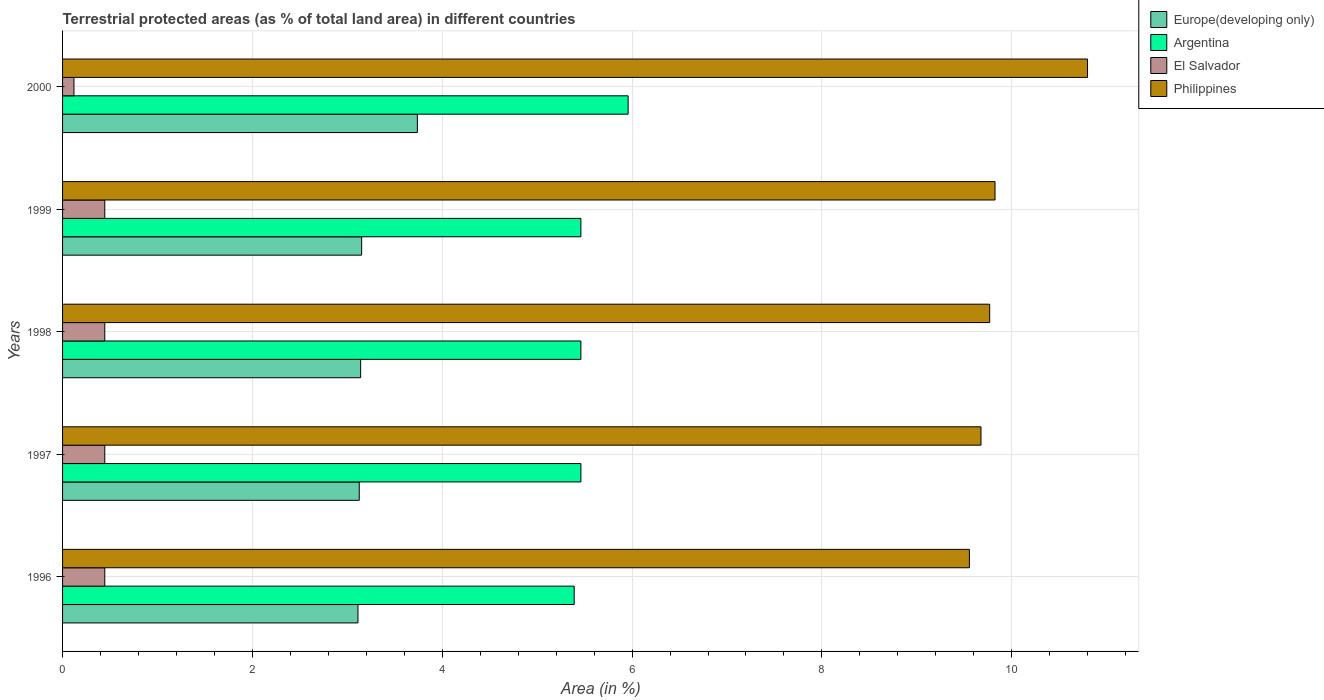How many groups of bars are there?
Ensure brevity in your answer.  5. Are the number of bars on each tick of the Y-axis equal?
Keep it short and to the point. Yes. How many bars are there on the 3rd tick from the bottom?
Provide a short and direct response. 4. What is the label of the 3rd group of bars from the top?
Ensure brevity in your answer.  1998. What is the percentage of terrestrial protected land in Argentina in 2000?
Make the answer very short. 5.96. Across all years, what is the maximum percentage of terrestrial protected land in Argentina?
Offer a terse response. 5.96. Across all years, what is the minimum percentage of terrestrial protected land in Philippines?
Provide a succinct answer. 9.55. In which year was the percentage of terrestrial protected land in Philippines maximum?
Provide a short and direct response. 2000. In which year was the percentage of terrestrial protected land in Europe(developing only) minimum?
Your response must be concise. 1996. What is the total percentage of terrestrial protected land in El Salvador in the graph?
Your response must be concise. 1.9. What is the difference between the percentage of terrestrial protected land in Europe(developing only) in 1996 and that in 1999?
Keep it short and to the point. -0.04. What is the difference between the percentage of terrestrial protected land in Argentina in 1996 and the percentage of terrestrial protected land in El Salvador in 1998?
Your answer should be very brief. 4.95. What is the average percentage of terrestrial protected land in Argentina per year?
Offer a very short reply. 5.55. In the year 1996, what is the difference between the percentage of terrestrial protected land in El Salvador and percentage of terrestrial protected land in Europe(developing only)?
Provide a short and direct response. -2.67. In how many years, is the percentage of terrestrial protected land in Philippines greater than 0.8 %?
Make the answer very short. 5. What is the ratio of the percentage of terrestrial protected land in Philippines in 1996 to that in 2000?
Your response must be concise. 0.88. Is the percentage of terrestrial protected land in El Salvador in 1996 less than that in 2000?
Offer a very short reply. No. Is the difference between the percentage of terrestrial protected land in El Salvador in 1996 and 2000 greater than the difference between the percentage of terrestrial protected land in Europe(developing only) in 1996 and 2000?
Keep it short and to the point. Yes. What is the difference between the highest and the second highest percentage of terrestrial protected land in El Salvador?
Your answer should be very brief. 0. What is the difference between the highest and the lowest percentage of terrestrial protected land in Europe(developing only)?
Offer a terse response. 0.63. Is the sum of the percentage of terrestrial protected land in El Salvador in 1999 and 2000 greater than the maximum percentage of terrestrial protected land in Argentina across all years?
Provide a short and direct response. No. What does the 4th bar from the top in 1997 represents?
Your response must be concise. Europe(developing only). What does the 2nd bar from the bottom in 1996 represents?
Your answer should be very brief. Argentina. Is it the case that in every year, the sum of the percentage of terrestrial protected land in Europe(developing only) and percentage of terrestrial protected land in El Salvador is greater than the percentage of terrestrial protected land in Philippines?
Provide a succinct answer. No. Are all the bars in the graph horizontal?
Give a very brief answer. Yes. How many years are there in the graph?
Offer a terse response. 5. What is the difference between two consecutive major ticks on the X-axis?
Give a very brief answer. 2. Are the values on the major ticks of X-axis written in scientific E-notation?
Ensure brevity in your answer.  No. How many legend labels are there?
Give a very brief answer. 4. What is the title of the graph?
Provide a short and direct response. Terrestrial protected areas (as % of total land area) in different countries. What is the label or title of the X-axis?
Offer a very short reply. Area (in %). What is the label or title of the Y-axis?
Provide a succinct answer. Years. What is the Area (in %) of Europe(developing only) in 1996?
Give a very brief answer. 3.11. What is the Area (in %) of Argentina in 1996?
Offer a terse response. 5.39. What is the Area (in %) of El Salvador in 1996?
Your answer should be compact. 0.44. What is the Area (in %) of Philippines in 1996?
Your answer should be very brief. 9.55. What is the Area (in %) in Europe(developing only) in 1997?
Offer a terse response. 3.13. What is the Area (in %) of Argentina in 1997?
Provide a succinct answer. 5.46. What is the Area (in %) in El Salvador in 1997?
Your answer should be compact. 0.44. What is the Area (in %) of Philippines in 1997?
Ensure brevity in your answer.  9.68. What is the Area (in %) of Europe(developing only) in 1998?
Your response must be concise. 3.14. What is the Area (in %) in Argentina in 1998?
Your answer should be very brief. 5.46. What is the Area (in %) in El Salvador in 1998?
Keep it short and to the point. 0.44. What is the Area (in %) of Philippines in 1998?
Offer a very short reply. 9.77. What is the Area (in %) in Europe(developing only) in 1999?
Your response must be concise. 3.15. What is the Area (in %) in Argentina in 1999?
Offer a very short reply. 5.46. What is the Area (in %) in El Salvador in 1999?
Offer a terse response. 0.44. What is the Area (in %) in Philippines in 1999?
Offer a terse response. 9.82. What is the Area (in %) of Europe(developing only) in 2000?
Your answer should be compact. 3.74. What is the Area (in %) of Argentina in 2000?
Your answer should be compact. 5.96. What is the Area (in %) of El Salvador in 2000?
Make the answer very short. 0.12. What is the Area (in %) of Philippines in 2000?
Your answer should be compact. 10.8. Across all years, what is the maximum Area (in %) in Europe(developing only)?
Offer a very short reply. 3.74. Across all years, what is the maximum Area (in %) of Argentina?
Provide a short and direct response. 5.96. Across all years, what is the maximum Area (in %) of El Salvador?
Offer a terse response. 0.44. Across all years, what is the maximum Area (in %) of Philippines?
Your response must be concise. 10.8. Across all years, what is the minimum Area (in %) in Europe(developing only)?
Offer a terse response. 3.11. Across all years, what is the minimum Area (in %) of Argentina?
Ensure brevity in your answer.  5.39. Across all years, what is the minimum Area (in %) in El Salvador?
Offer a terse response. 0.12. Across all years, what is the minimum Area (in %) in Philippines?
Provide a succinct answer. 9.55. What is the total Area (in %) in Europe(developing only) in the graph?
Make the answer very short. 16.27. What is the total Area (in %) of Argentina in the graph?
Your response must be concise. 27.73. What is the total Area (in %) of El Salvador in the graph?
Offer a terse response. 1.9. What is the total Area (in %) in Philippines in the graph?
Keep it short and to the point. 49.62. What is the difference between the Area (in %) of Europe(developing only) in 1996 and that in 1997?
Offer a terse response. -0.01. What is the difference between the Area (in %) of Argentina in 1996 and that in 1997?
Offer a very short reply. -0.07. What is the difference between the Area (in %) of Philippines in 1996 and that in 1997?
Offer a terse response. -0.12. What is the difference between the Area (in %) of Europe(developing only) in 1996 and that in 1998?
Your answer should be compact. -0.03. What is the difference between the Area (in %) in Argentina in 1996 and that in 1998?
Your answer should be very brief. -0.07. What is the difference between the Area (in %) of El Salvador in 1996 and that in 1998?
Provide a succinct answer. 0. What is the difference between the Area (in %) of Philippines in 1996 and that in 1998?
Your answer should be compact. -0.21. What is the difference between the Area (in %) in Europe(developing only) in 1996 and that in 1999?
Provide a short and direct response. -0.04. What is the difference between the Area (in %) of Argentina in 1996 and that in 1999?
Provide a succinct answer. -0.07. What is the difference between the Area (in %) of El Salvador in 1996 and that in 1999?
Ensure brevity in your answer.  0. What is the difference between the Area (in %) of Philippines in 1996 and that in 1999?
Keep it short and to the point. -0.27. What is the difference between the Area (in %) of Europe(developing only) in 1996 and that in 2000?
Your response must be concise. -0.63. What is the difference between the Area (in %) of Argentina in 1996 and that in 2000?
Keep it short and to the point. -0.57. What is the difference between the Area (in %) in El Salvador in 1996 and that in 2000?
Offer a terse response. 0.32. What is the difference between the Area (in %) in Philippines in 1996 and that in 2000?
Make the answer very short. -1.24. What is the difference between the Area (in %) of Europe(developing only) in 1997 and that in 1998?
Ensure brevity in your answer.  -0.01. What is the difference between the Area (in %) in Argentina in 1997 and that in 1998?
Your answer should be compact. -0. What is the difference between the Area (in %) of El Salvador in 1997 and that in 1998?
Make the answer very short. 0. What is the difference between the Area (in %) of Philippines in 1997 and that in 1998?
Your answer should be compact. -0.09. What is the difference between the Area (in %) of Europe(developing only) in 1997 and that in 1999?
Make the answer very short. -0.03. What is the difference between the Area (in %) of Philippines in 1997 and that in 1999?
Offer a terse response. -0.15. What is the difference between the Area (in %) of Europe(developing only) in 1997 and that in 2000?
Your answer should be very brief. -0.61. What is the difference between the Area (in %) of Argentina in 1997 and that in 2000?
Provide a short and direct response. -0.5. What is the difference between the Area (in %) of El Salvador in 1997 and that in 2000?
Your response must be concise. 0.32. What is the difference between the Area (in %) in Philippines in 1997 and that in 2000?
Your answer should be compact. -1.12. What is the difference between the Area (in %) of Europe(developing only) in 1998 and that in 1999?
Give a very brief answer. -0.01. What is the difference between the Area (in %) in El Salvador in 1998 and that in 1999?
Make the answer very short. 0. What is the difference between the Area (in %) in Philippines in 1998 and that in 1999?
Offer a terse response. -0.06. What is the difference between the Area (in %) in Europe(developing only) in 1998 and that in 2000?
Offer a terse response. -0.6. What is the difference between the Area (in %) of Argentina in 1998 and that in 2000?
Provide a short and direct response. -0.5. What is the difference between the Area (in %) of El Salvador in 1998 and that in 2000?
Ensure brevity in your answer.  0.32. What is the difference between the Area (in %) of Philippines in 1998 and that in 2000?
Provide a succinct answer. -1.03. What is the difference between the Area (in %) in Europe(developing only) in 1999 and that in 2000?
Give a very brief answer. -0.59. What is the difference between the Area (in %) of Argentina in 1999 and that in 2000?
Offer a very short reply. -0.5. What is the difference between the Area (in %) of El Salvador in 1999 and that in 2000?
Your response must be concise. 0.32. What is the difference between the Area (in %) in Philippines in 1999 and that in 2000?
Provide a succinct answer. -0.97. What is the difference between the Area (in %) of Europe(developing only) in 1996 and the Area (in %) of Argentina in 1997?
Offer a very short reply. -2.35. What is the difference between the Area (in %) in Europe(developing only) in 1996 and the Area (in %) in El Salvador in 1997?
Ensure brevity in your answer.  2.67. What is the difference between the Area (in %) in Europe(developing only) in 1996 and the Area (in %) in Philippines in 1997?
Your answer should be very brief. -6.56. What is the difference between the Area (in %) of Argentina in 1996 and the Area (in %) of El Salvador in 1997?
Provide a short and direct response. 4.95. What is the difference between the Area (in %) of Argentina in 1996 and the Area (in %) of Philippines in 1997?
Provide a succinct answer. -4.29. What is the difference between the Area (in %) in El Salvador in 1996 and the Area (in %) in Philippines in 1997?
Give a very brief answer. -9.23. What is the difference between the Area (in %) in Europe(developing only) in 1996 and the Area (in %) in Argentina in 1998?
Offer a very short reply. -2.35. What is the difference between the Area (in %) of Europe(developing only) in 1996 and the Area (in %) of El Salvador in 1998?
Provide a succinct answer. 2.67. What is the difference between the Area (in %) in Europe(developing only) in 1996 and the Area (in %) in Philippines in 1998?
Offer a very short reply. -6.66. What is the difference between the Area (in %) in Argentina in 1996 and the Area (in %) in El Salvador in 1998?
Ensure brevity in your answer.  4.95. What is the difference between the Area (in %) of Argentina in 1996 and the Area (in %) of Philippines in 1998?
Your answer should be very brief. -4.38. What is the difference between the Area (in %) in El Salvador in 1996 and the Area (in %) in Philippines in 1998?
Make the answer very short. -9.32. What is the difference between the Area (in %) in Europe(developing only) in 1996 and the Area (in %) in Argentina in 1999?
Ensure brevity in your answer.  -2.35. What is the difference between the Area (in %) in Europe(developing only) in 1996 and the Area (in %) in El Salvador in 1999?
Offer a terse response. 2.67. What is the difference between the Area (in %) of Europe(developing only) in 1996 and the Area (in %) of Philippines in 1999?
Keep it short and to the point. -6.71. What is the difference between the Area (in %) of Argentina in 1996 and the Area (in %) of El Salvador in 1999?
Provide a succinct answer. 4.95. What is the difference between the Area (in %) in Argentina in 1996 and the Area (in %) in Philippines in 1999?
Your answer should be very brief. -4.43. What is the difference between the Area (in %) of El Salvador in 1996 and the Area (in %) of Philippines in 1999?
Keep it short and to the point. -9.38. What is the difference between the Area (in %) of Europe(developing only) in 1996 and the Area (in %) of Argentina in 2000?
Keep it short and to the point. -2.85. What is the difference between the Area (in %) in Europe(developing only) in 1996 and the Area (in %) in El Salvador in 2000?
Your response must be concise. 2.99. What is the difference between the Area (in %) in Europe(developing only) in 1996 and the Area (in %) in Philippines in 2000?
Your answer should be compact. -7.69. What is the difference between the Area (in %) in Argentina in 1996 and the Area (in %) in El Salvador in 2000?
Offer a terse response. 5.27. What is the difference between the Area (in %) of Argentina in 1996 and the Area (in %) of Philippines in 2000?
Your response must be concise. -5.41. What is the difference between the Area (in %) in El Salvador in 1996 and the Area (in %) in Philippines in 2000?
Give a very brief answer. -10.35. What is the difference between the Area (in %) of Europe(developing only) in 1997 and the Area (in %) of Argentina in 1998?
Provide a succinct answer. -2.34. What is the difference between the Area (in %) in Europe(developing only) in 1997 and the Area (in %) in El Salvador in 1998?
Ensure brevity in your answer.  2.68. What is the difference between the Area (in %) in Europe(developing only) in 1997 and the Area (in %) in Philippines in 1998?
Provide a succinct answer. -6.64. What is the difference between the Area (in %) of Argentina in 1997 and the Area (in %) of El Salvador in 1998?
Keep it short and to the point. 5.02. What is the difference between the Area (in %) in Argentina in 1997 and the Area (in %) in Philippines in 1998?
Make the answer very short. -4.31. What is the difference between the Area (in %) in El Salvador in 1997 and the Area (in %) in Philippines in 1998?
Provide a succinct answer. -9.32. What is the difference between the Area (in %) in Europe(developing only) in 1997 and the Area (in %) in Argentina in 1999?
Keep it short and to the point. -2.34. What is the difference between the Area (in %) in Europe(developing only) in 1997 and the Area (in %) in El Salvador in 1999?
Offer a terse response. 2.68. What is the difference between the Area (in %) in Europe(developing only) in 1997 and the Area (in %) in Philippines in 1999?
Ensure brevity in your answer.  -6.7. What is the difference between the Area (in %) in Argentina in 1997 and the Area (in %) in El Salvador in 1999?
Provide a succinct answer. 5.02. What is the difference between the Area (in %) in Argentina in 1997 and the Area (in %) in Philippines in 1999?
Make the answer very short. -4.36. What is the difference between the Area (in %) of El Salvador in 1997 and the Area (in %) of Philippines in 1999?
Give a very brief answer. -9.38. What is the difference between the Area (in %) of Europe(developing only) in 1997 and the Area (in %) of Argentina in 2000?
Offer a very short reply. -2.83. What is the difference between the Area (in %) in Europe(developing only) in 1997 and the Area (in %) in El Salvador in 2000?
Offer a terse response. 3.01. What is the difference between the Area (in %) in Europe(developing only) in 1997 and the Area (in %) in Philippines in 2000?
Your response must be concise. -7.67. What is the difference between the Area (in %) of Argentina in 1997 and the Area (in %) of El Salvador in 2000?
Your answer should be very brief. 5.34. What is the difference between the Area (in %) in Argentina in 1997 and the Area (in %) in Philippines in 2000?
Provide a short and direct response. -5.34. What is the difference between the Area (in %) in El Salvador in 1997 and the Area (in %) in Philippines in 2000?
Your answer should be compact. -10.35. What is the difference between the Area (in %) in Europe(developing only) in 1998 and the Area (in %) in Argentina in 1999?
Your answer should be very brief. -2.32. What is the difference between the Area (in %) in Europe(developing only) in 1998 and the Area (in %) in El Salvador in 1999?
Your response must be concise. 2.7. What is the difference between the Area (in %) in Europe(developing only) in 1998 and the Area (in %) in Philippines in 1999?
Give a very brief answer. -6.68. What is the difference between the Area (in %) in Argentina in 1998 and the Area (in %) in El Salvador in 1999?
Your answer should be compact. 5.02. What is the difference between the Area (in %) in Argentina in 1998 and the Area (in %) in Philippines in 1999?
Make the answer very short. -4.36. What is the difference between the Area (in %) of El Salvador in 1998 and the Area (in %) of Philippines in 1999?
Make the answer very short. -9.38. What is the difference between the Area (in %) of Europe(developing only) in 1998 and the Area (in %) of Argentina in 2000?
Keep it short and to the point. -2.82. What is the difference between the Area (in %) in Europe(developing only) in 1998 and the Area (in %) in El Salvador in 2000?
Provide a succinct answer. 3.02. What is the difference between the Area (in %) of Europe(developing only) in 1998 and the Area (in %) of Philippines in 2000?
Give a very brief answer. -7.66. What is the difference between the Area (in %) of Argentina in 1998 and the Area (in %) of El Salvador in 2000?
Keep it short and to the point. 5.34. What is the difference between the Area (in %) in Argentina in 1998 and the Area (in %) in Philippines in 2000?
Offer a terse response. -5.34. What is the difference between the Area (in %) in El Salvador in 1998 and the Area (in %) in Philippines in 2000?
Provide a succinct answer. -10.35. What is the difference between the Area (in %) in Europe(developing only) in 1999 and the Area (in %) in Argentina in 2000?
Give a very brief answer. -2.81. What is the difference between the Area (in %) of Europe(developing only) in 1999 and the Area (in %) of El Salvador in 2000?
Make the answer very short. 3.03. What is the difference between the Area (in %) in Europe(developing only) in 1999 and the Area (in %) in Philippines in 2000?
Give a very brief answer. -7.65. What is the difference between the Area (in %) in Argentina in 1999 and the Area (in %) in El Salvador in 2000?
Your answer should be very brief. 5.34. What is the difference between the Area (in %) of Argentina in 1999 and the Area (in %) of Philippines in 2000?
Your answer should be very brief. -5.34. What is the difference between the Area (in %) in El Salvador in 1999 and the Area (in %) in Philippines in 2000?
Ensure brevity in your answer.  -10.35. What is the average Area (in %) in Europe(developing only) per year?
Provide a succinct answer. 3.25. What is the average Area (in %) in Argentina per year?
Keep it short and to the point. 5.55. What is the average Area (in %) in El Salvador per year?
Your response must be concise. 0.38. What is the average Area (in %) in Philippines per year?
Offer a very short reply. 9.92. In the year 1996, what is the difference between the Area (in %) in Europe(developing only) and Area (in %) in Argentina?
Ensure brevity in your answer.  -2.28. In the year 1996, what is the difference between the Area (in %) of Europe(developing only) and Area (in %) of El Salvador?
Make the answer very short. 2.67. In the year 1996, what is the difference between the Area (in %) in Europe(developing only) and Area (in %) in Philippines?
Provide a short and direct response. -6.44. In the year 1996, what is the difference between the Area (in %) in Argentina and Area (in %) in El Salvador?
Ensure brevity in your answer.  4.95. In the year 1996, what is the difference between the Area (in %) in Argentina and Area (in %) in Philippines?
Provide a short and direct response. -4.16. In the year 1996, what is the difference between the Area (in %) of El Salvador and Area (in %) of Philippines?
Your response must be concise. -9.11. In the year 1997, what is the difference between the Area (in %) of Europe(developing only) and Area (in %) of Argentina?
Provide a succinct answer. -2.33. In the year 1997, what is the difference between the Area (in %) in Europe(developing only) and Area (in %) in El Salvador?
Offer a terse response. 2.68. In the year 1997, what is the difference between the Area (in %) in Europe(developing only) and Area (in %) in Philippines?
Your answer should be compact. -6.55. In the year 1997, what is the difference between the Area (in %) of Argentina and Area (in %) of El Salvador?
Provide a succinct answer. 5.02. In the year 1997, what is the difference between the Area (in %) of Argentina and Area (in %) of Philippines?
Give a very brief answer. -4.21. In the year 1997, what is the difference between the Area (in %) in El Salvador and Area (in %) in Philippines?
Give a very brief answer. -9.23. In the year 1998, what is the difference between the Area (in %) of Europe(developing only) and Area (in %) of Argentina?
Your response must be concise. -2.32. In the year 1998, what is the difference between the Area (in %) in Europe(developing only) and Area (in %) in El Salvador?
Ensure brevity in your answer.  2.7. In the year 1998, what is the difference between the Area (in %) of Europe(developing only) and Area (in %) of Philippines?
Make the answer very short. -6.63. In the year 1998, what is the difference between the Area (in %) of Argentina and Area (in %) of El Salvador?
Offer a very short reply. 5.02. In the year 1998, what is the difference between the Area (in %) in Argentina and Area (in %) in Philippines?
Ensure brevity in your answer.  -4.31. In the year 1998, what is the difference between the Area (in %) of El Salvador and Area (in %) of Philippines?
Make the answer very short. -9.32. In the year 1999, what is the difference between the Area (in %) of Europe(developing only) and Area (in %) of Argentina?
Offer a terse response. -2.31. In the year 1999, what is the difference between the Area (in %) in Europe(developing only) and Area (in %) in El Salvador?
Keep it short and to the point. 2.71. In the year 1999, what is the difference between the Area (in %) in Europe(developing only) and Area (in %) in Philippines?
Keep it short and to the point. -6.67. In the year 1999, what is the difference between the Area (in %) of Argentina and Area (in %) of El Salvador?
Offer a very short reply. 5.02. In the year 1999, what is the difference between the Area (in %) of Argentina and Area (in %) of Philippines?
Make the answer very short. -4.36. In the year 1999, what is the difference between the Area (in %) of El Salvador and Area (in %) of Philippines?
Your response must be concise. -9.38. In the year 2000, what is the difference between the Area (in %) in Europe(developing only) and Area (in %) in Argentina?
Provide a succinct answer. -2.22. In the year 2000, what is the difference between the Area (in %) of Europe(developing only) and Area (in %) of El Salvador?
Your response must be concise. 3.62. In the year 2000, what is the difference between the Area (in %) of Europe(developing only) and Area (in %) of Philippines?
Provide a succinct answer. -7.06. In the year 2000, what is the difference between the Area (in %) in Argentina and Area (in %) in El Salvador?
Keep it short and to the point. 5.84. In the year 2000, what is the difference between the Area (in %) of Argentina and Area (in %) of Philippines?
Provide a succinct answer. -4.84. In the year 2000, what is the difference between the Area (in %) of El Salvador and Area (in %) of Philippines?
Make the answer very short. -10.68. What is the ratio of the Area (in %) in Argentina in 1996 to that in 1997?
Provide a succinct answer. 0.99. What is the ratio of the Area (in %) of Philippines in 1996 to that in 1997?
Your answer should be compact. 0.99. What is the ratio of the Area (in %) of Europe(developing only) in 1996 to that in 1998?
Your response must be concise. 0.99. What is the ratio of the Area (in %) of El Salvador in 1996 to that in 1998?
Your answer should be very brief. 1. What is the ratio of the Area (in %) of Philippines in 1996 to that in 1998?
Provide a short and direct response. 0.98. What is the ratio of the Area (in %) of Argentina in 1996 to that in 1999?
Your answer should be compact. 0.99. What is the ratio of the Area (in %) of El Salvador in 1996 to that in 1999?
Your response must be concise. 1. What is the ratio of the Area (in %) of Philippines in 1996 to that in 1999?
Offer a terse response. 0.97. What is the ratio of the Area (in %) of Europe(developing only) in 1996 to that in 2000?
Your response must be concise. 0.83. What is the ratio of the Area (in %) in Argentina in 1996 to that in 2000?
Provide a succinct answer. 0.9. What is the ratio of the Area (in %) in El Salvador in 1996 to that in 2000?
Make the answer very short. 3.7. What is the ratio of the Area (in %) in Philippines in 1996 to that in 2000?
Ensure brevity in your answer.  0.88. What is the ratio of the Area (in %) in Europe(developing only) in 1997 to that in 1998?
Keep it short and to the point. 1. What is the ratio of the Area (in %) of Philippines in 1997 to that in 1998?
Your answer should be very brief. 0.99. What is the ratio of the Area (in %) in El Salvador in 1997 to that in 1999?
Offer a terse response. 1. What is the ratio of the Area (in %) of Philippines in 1997 to that in 1999?
Provide a short and direct response. 0.98. What is the ratio of the Area (in %) of Europe(developing only) in 1997 to that in 2000?
Provide a short and direct response. 0.84. What is the ratio of the Area (in %) in Argentina in 1997 to that in 2000?
Provide a short and direct response. 0.92. What is the ratio of the Area (in %) in El Salvador in 1997 to that in 2000?
Offer a terse response. 3.7. What is the ratio of the Area (in %) in Philippines in 1997 to that in 2000?
Provide a succinct answer. 0.9. What is the ratio of the Area (in %) of Europe(developing only) in 1998 to that in 1999?
Offer a terse response. 1. What is the ratio of the Area (in %) in Argentina in 1998 to that in 1999?
Offer a terse response. 1. What is the ratio of the Area (in %) of El Salvador in 1998 to that in 1999?
Your answer should be very brief. 1. What is the ratio of the Area (in %) of Philippines in 1998 to that in 1999?
Offer a very short reply. 0.99. What is the ratio of the Area (in %) of Europe(developing only) in 1998 to that in 2000?
Offer a terse response. 0.84. What is the ratio of the Area (in %) of Argentina in 1998 to that in 2000?
Your response must be concise. 0.92. What is the ratio of the Area (in %) of El Salvador in 1998 to that in 2000?
Keep it short and to the point. 3.7. What is the ratio of the Area (in %) of Philippines in 1998 to that in 2000?
Give a very brief answer. 0.9. What is the ratio of the Area (in %) in Europe(developing only) in 1999 to that in 2000?
Offer a terse response. 0.84. What is the ratio of the Area (in %) in Argentina in 1999 to that in 2000?
Offer a very short reply. 0.92. What is the ratio of the Area (in %) in El Salvador in 1999 to that in 2000?
Your answer should be very brief. 3.7. What is the ratio of the Area (in %) of Philippines in 1999 to that in 2000?
Offer a terse response. 0.91. What is the difference between the highest and the second highest Area (in %) in Europe(developing only)?
Your answer should be very brief. 0.59. What is the difference between the highest and the second highest Area (in %) of Argentina?
Provide a short and direct response. 0.5. What is the difference between the highest and the second highest Area (in %) in Philippines?
Provide a succinct answer. 0.97. What is the difference between the highest and the lowest Area (in %) of Europe(developing only)?
Give a very brief answer. 0.63. What is the difference between the highest and the lowest Area (in %) of Argentina?
Your answer should be compact. 0.57. What is the difference between the highest and the lowest Area (in %) in El Salvador?
Ensure brevity in your answer.  0.32. What is the difference between the highest and the lowest Area (in %) in Philippines?
Provide a short and direct response. 1.24. 